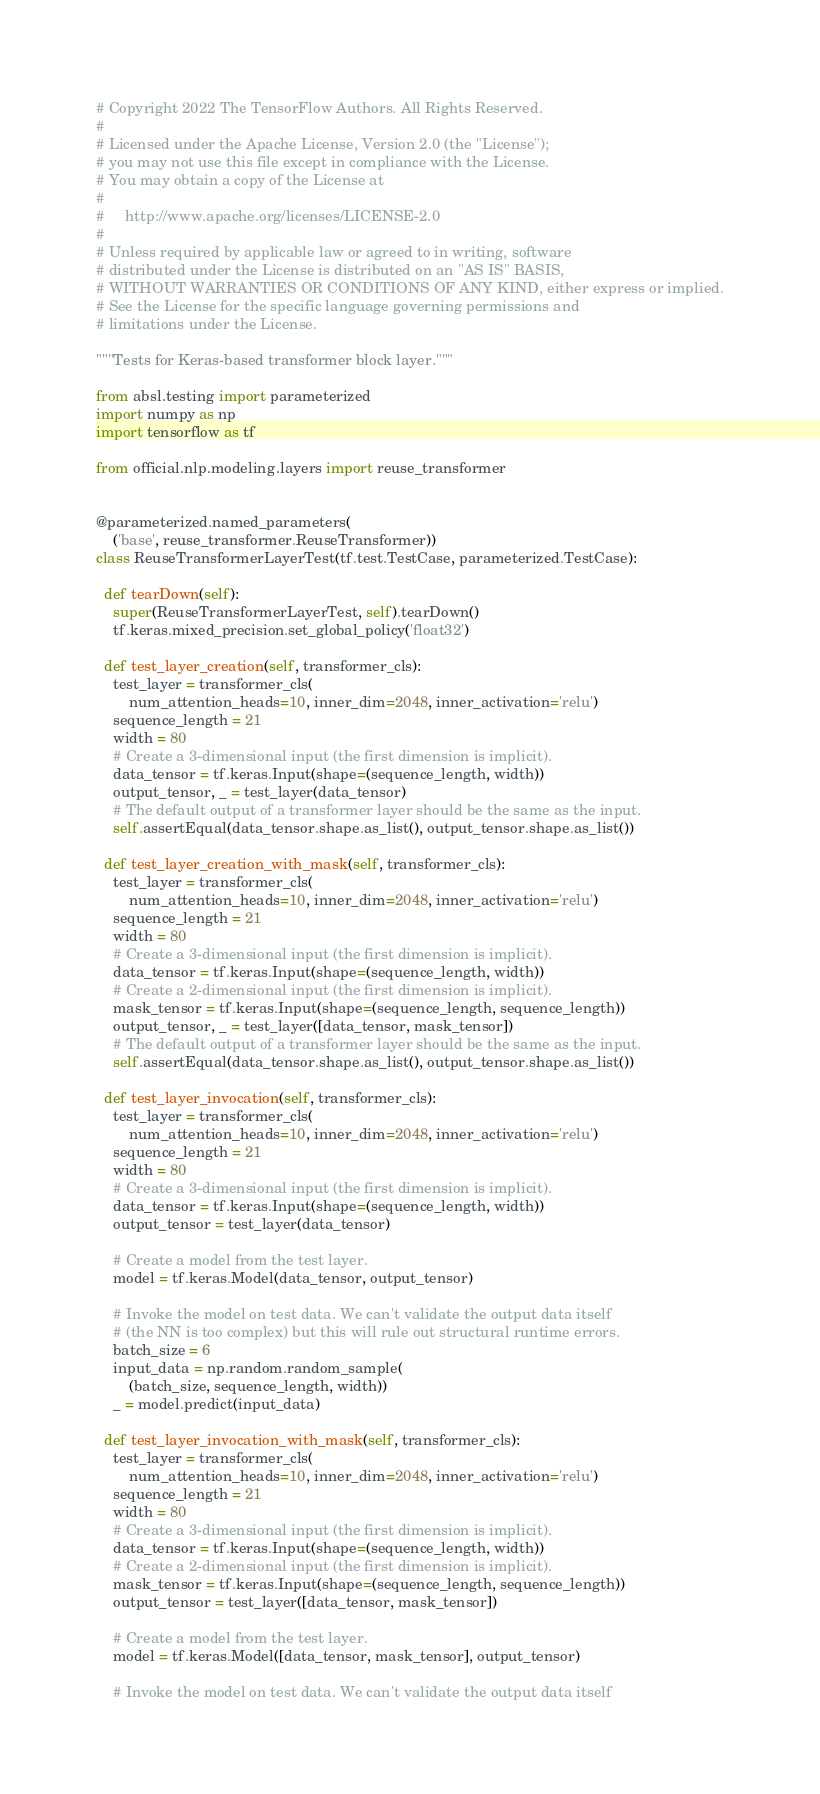<code> <loc_0><loc_0><loc_500><loc_500><_Python_># Copyright 2022 The TensorFlow Authors. All Rights Reserved.
#
# Licensed under the Apache License, Version 2.0 (the "License");
# you may not use this file except in compliance with the License.
# You may obtain a copy of the License at
#
#     http://www.apache.org/licenses/LICENSE-2.0
#
# Unless required by applicable law or agreed to in writing, software
# distributed under the License is distributed on an "AS IS" BASIS,
# WITHOUT WARRANTIES OR CONDITIONS OF ANY KIND, either express or implied.
# See the License for the specific language governing permissions and
# limitations under the License.

"""Tests for Keras-based transformer block layer."""

from absl.testing import parameterized
import numpy as np
import tensorflow as tf

from official.nlp.modeling.layers import reuse_transformer


@parameterized.named_parameters(
    ('base', reuse_transformer.ReuseTransformer))
class ReuseTransformerLayerTest(tf.test.TestCase, parameterized.TestCase):

  def tearDown(self):
    super(ReuseTransformerLayerTest, self).tearDown()
    tf.keras.mixed_precision.set_global_policy('float32')

  def test_layer_creation(self, transformer_cls):
    test_layer = transformer_cls(
        num_attention_heads=10, inner_dim=2048, inner_activation='relu')
    sequence_length = 21
    width = 80
    # Create a 3-dimensional input (the first dimension is implicit).
    data_tensor = tf.keras.Input(shape=(sequence_length, width))
    output_tensor, _ = test_layer(data_tensor)
    # The default output of a transformer layer should be the same as the input.
    self.assertEqual(data_tensor.shape.as_list(), output_tensor.shape.as_list())

  def test_layer_creation_with_mask(self, transformer_cls):
    test_layer = transformer_cls(
        num_attention_heads=10, inner_dim=2048, inner_activation='relu')
    sequence_length = 21
    width = 80
    # Create a 3-dimensional input (the first dimension is implicit).
    data_tensor = tf.keras.Input(shape=(sequence_length, width))
    # Create a 2-dimensional input (the first dimension is implicit).
    mask_tensor = tf.keras.Input(shape=(sequence_length, sequence_length))
    output_tensor, _ = test_layer([data_tensor, mask_tensor])
    # The default output of a transformer layer should be the same as the input.
    self.assertEqual(data_tensor.shape.as_list(), output_tensor.shape.as_list())

  def test_layer_invocation(self, transformer_cls):
    test_layer = transformer_cls(
        num_attention_heads=10, inner_dim=2048, inner_activation='relu')
    sequence_length = 21
    width = 80
    # Create a 3-dimensional input (the first dimension is implicit).
    data_tensor = tf.keras.Input(shape=(sequence_length, width))
    output_tensor = test_layer(data_tensor)

    # Create a model from the test layer.
    model = tf.keras.Model(data_tensor, output_tensor)

    # Invoke the model on test data. We can't validate the output data itself
    # (the NN is too complex) but this will rule out structural runtime errors.
    batch_size = 6
    input_data = np.random.random_sample(
        (batch_size, sequence_length, width))
    _ = model.predict(input_data)

  def test_layer_invocation_with_mask(self, transformer_cls):
    test_layer = transformer_cls(
        num_attention_heads=10, inner_dim=2048, inner_activation='relu')
    sequence_length = 21
    width = 80
    # Create a 3-dimensional input (the first dimension is implicit).
    data_tensor = tf.keras.Input(shape=(sequence_length, width))
    # Create a 2-dimensional input (the first dimension is implicit).
    mask_tensor = tf.keras.Input(shape=(sequence_length, sequence_length))
    output_tensor = test_layer([data_tensor, mask_tensor])

    # Create a model from the test layer.
    model = tf.keras.Model([data_tensor, mask_tensor], output_tensor)

    # Invoke the model on test data. We can't validate the output data itself</code> 